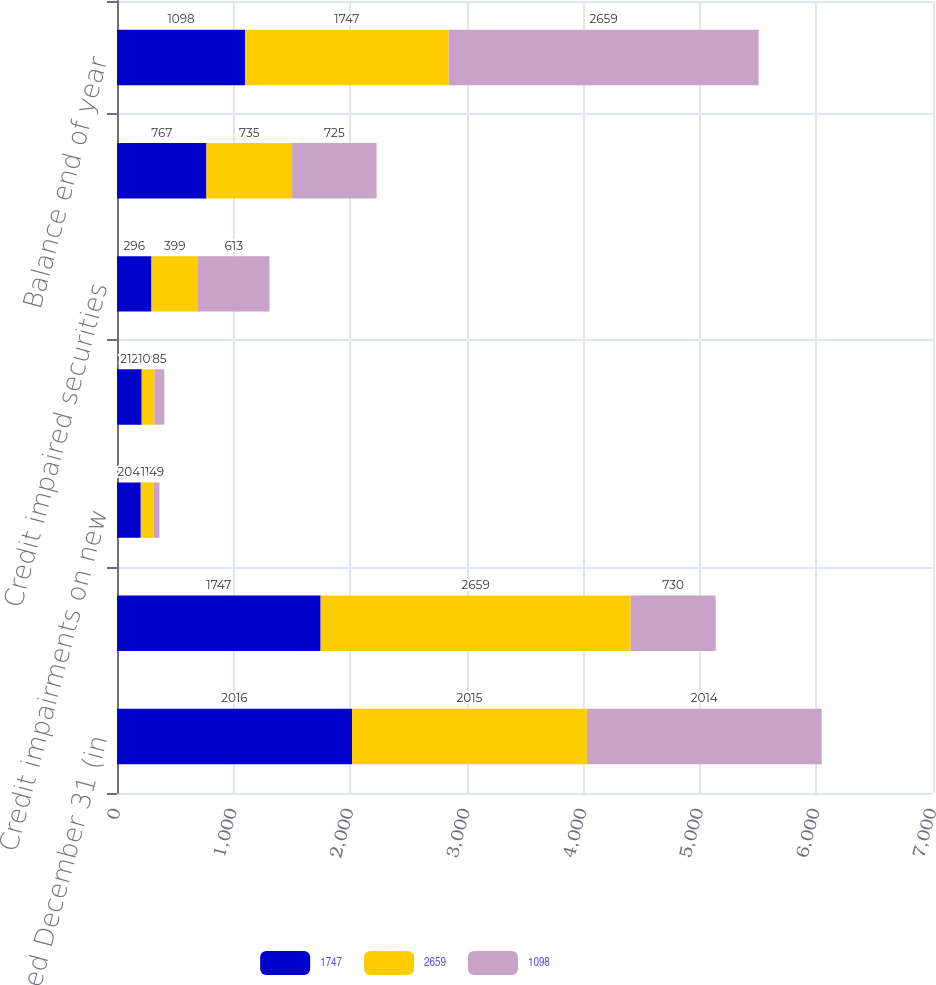<chart> <loc_0><loc_0><loc_500><loc_500><stacked_bar_chart><ecel><fcel>Years Ended December 31 (in<fcel>Balance beginning of year<fcel>Credit impairments on new<fcel>Additional credit impairments<fcel>Credit impaired securities<fcel>Accretion on securities<fcel>Balance end of year<nl><fcel>1747<fcel>2016<fcel>1747<fcel>204<fcel>212<fcel>296<fcel>767<fcel>1098<nl><fcel>2659<fcel>2015<fcel>2659<fcel>111<fcel>109<fcel>399<fcel>735<fcel>1747<nl><fcel>1098<fcel>2014<fcel>730<fcel>49<fcel>85<fcel>613<fcel>725<fcel>2659<nl></chart> 